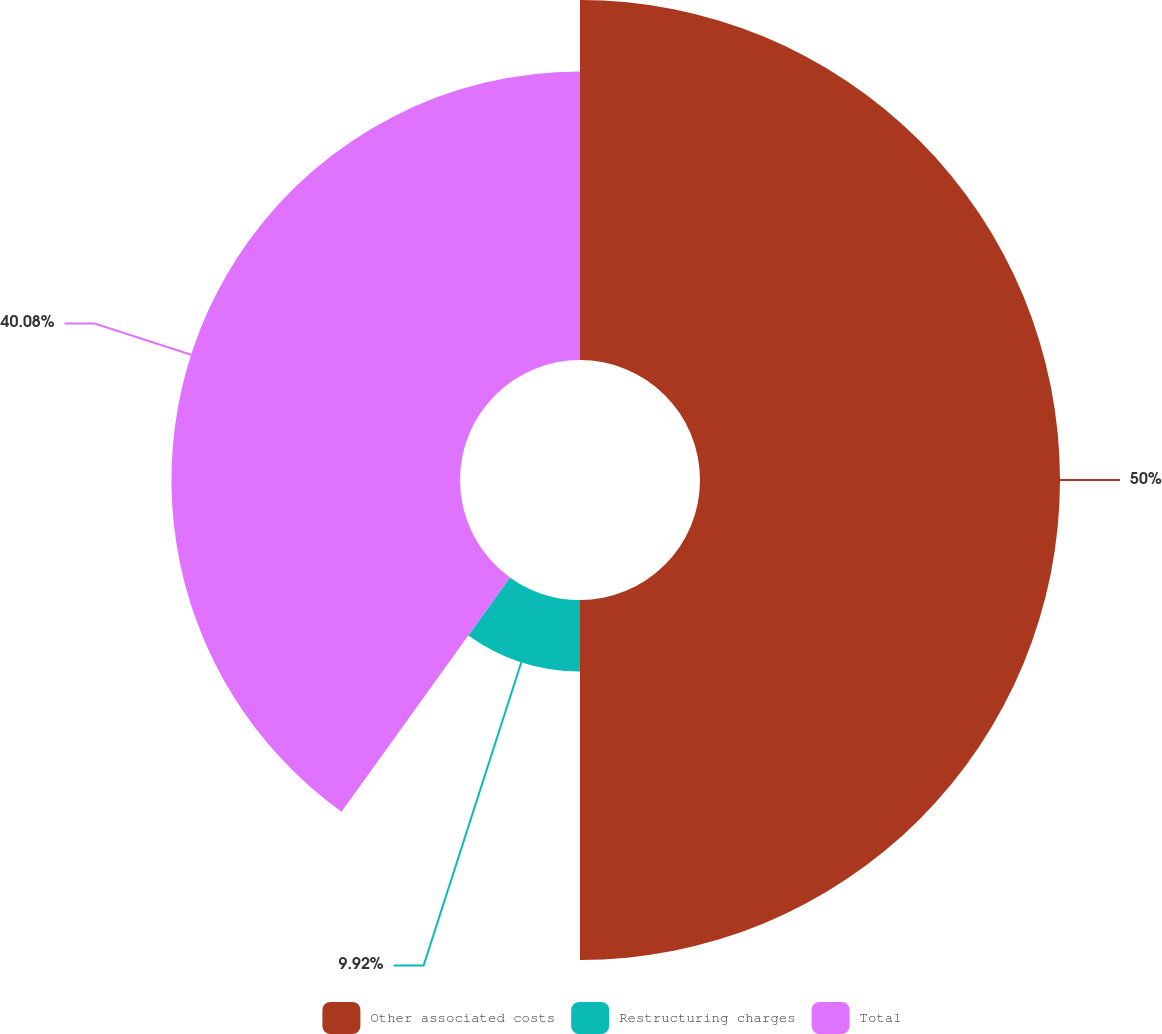Convert chart to OTSL. <chart><loc_0><loc_0><loc_500><loc_500><pie_chart><fcel>Other associated costs<fcel>Restructuring charges<fcel>Total<nl><fcel>50.0%<fcel>9.92%<fcel>40.08%<nl></chart> 